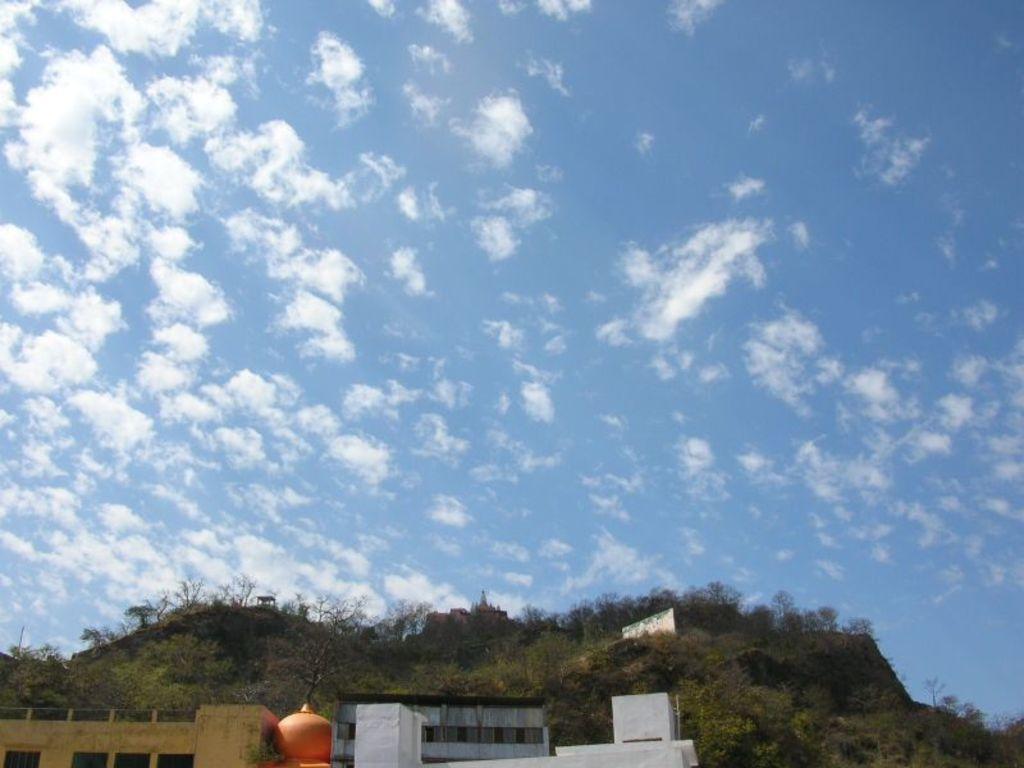How would you summarize this image in a sentence or two? In the image we can see there are buildings and behind there are lot of trees on the hill. 